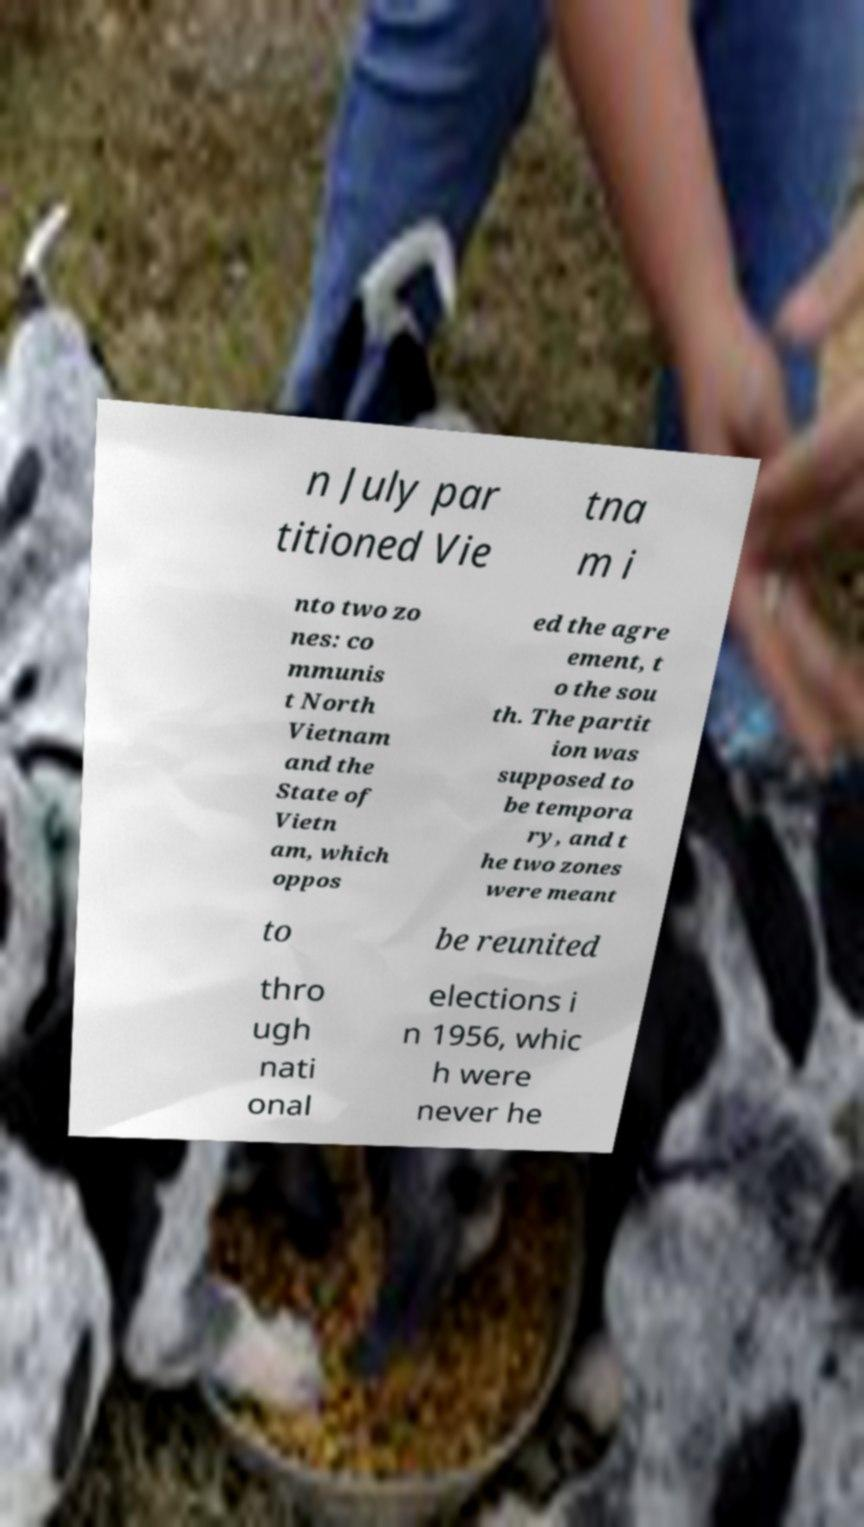There's text embedded in this image that I need extracted. Can you transcribe it verbatim? n July par titioned Vie tna m i nto two zo nes: co mmunis t North Vietnam and the State of Vietn am, which oppos ed the agre ement, t o the sou th. The partit ion was supposed to be tempora ry, and t he two zones were meant to be reunited thro ugh nati onal elections i n 1956, whic h were never he 